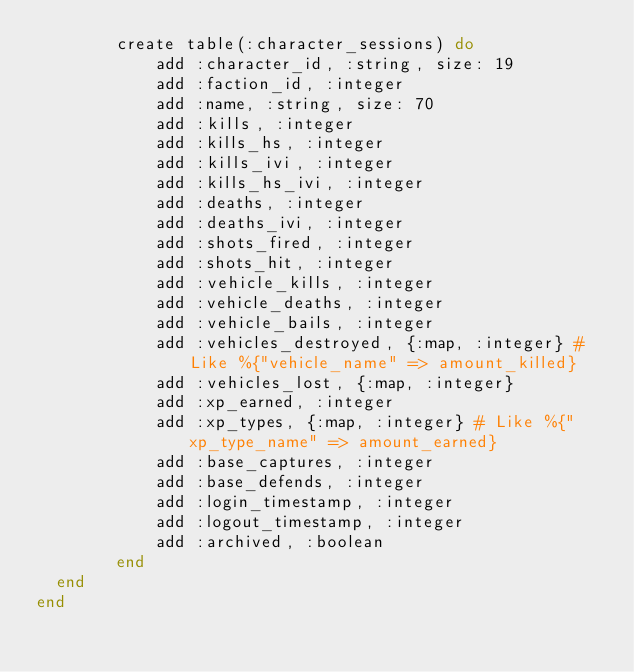Convert code to text. <code><loc_0><loc_0><loc_500><loc_500><_Elixir_>		create table(:character_sessions) do
			add :character_id, :string, size: 19
			add :faction_id, :integer
			add :name, :string, size: 70
			add :kills, :integer
			add :kills_hs, :integer
			add :kills_ivi, :integer
			add :kills_hs_ivi, :integer
			add :deaths, :integer
			add :deaths_ivi, :integer
			add :shots_fired, :integer
			add :shots_hit, :integer
			add :vehicle_kills, :integer
			add :vehicle_deaths, :integer
			add :vehicle_bails, :integer
			add :vehicles_destroyed, {:map, :integer} # Like %{"vehicle_name" => amount_killed}
			add :vehicles_lost, {:map, :integer}
			add :xp_earned, :integer
			add :xp_types, {:map, :integer} # Like %{"xp_type_name" => amount_earned}
			add :base_captures, :integer
			add :base_defends, :integer
			add :login_timestamp, :integer
			add :logout_timestamp, :integer
			add :archived, :boolean
		end
  end
end
</code> 